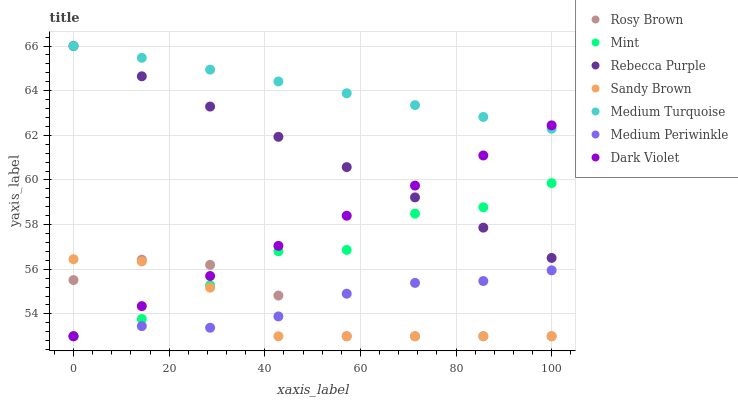Does Sandy Brown have the minimum area under the curve?
Answer yes or no. Yes. Does Medium Turquoise have the maximum area under the curve?
Answer yes or no. Yes. Does Rosy Brown have the minimum area under the curve?
Answer yes or no. No. Does Rosy Brown have the maximum area under the curve?
Answer yes or no. No. Is Dark Violet the smoothest?
Answer yes or no. Yes. Is Mint the roughest?
Answer yes or no. Yes. Is Rosy Brown the smoothest?
Answer yes or no. No. Is Rosy Brown the roughest?
Answer yes or no. No. Does Mint have the lowest value?
Answer yes or no. Yes. Does Rebecca Purple have the lowest value?
Answer yes or no. No. Does Medium Turquoise have the highest value?
Answer yes or no. Yes. Does Rosy Brown have the highest value?
Answer yes or no. No. Is Mint less than Medium Turquoise?
Answer yes or no. Yes. Is Medium Turquoise greater than Mint?
Answer yes or no. Yes. Does Rosy Brown intersect Medium Periwinkle?
Answer yes or no. Yes. Is Rosy Brown less than Medium Periwinkle?
Answer yes or no. No. Is Rosy Brown greater than Medium Periwinkle?
Answer yes or no. No. Does Mint intersect Medium Turquoise?
Answer yes or no. No. 